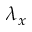Convert formula to latex. <formula><loc_0><loc_0><loc_500><loc_500>\lambda _ { x }</formula> 